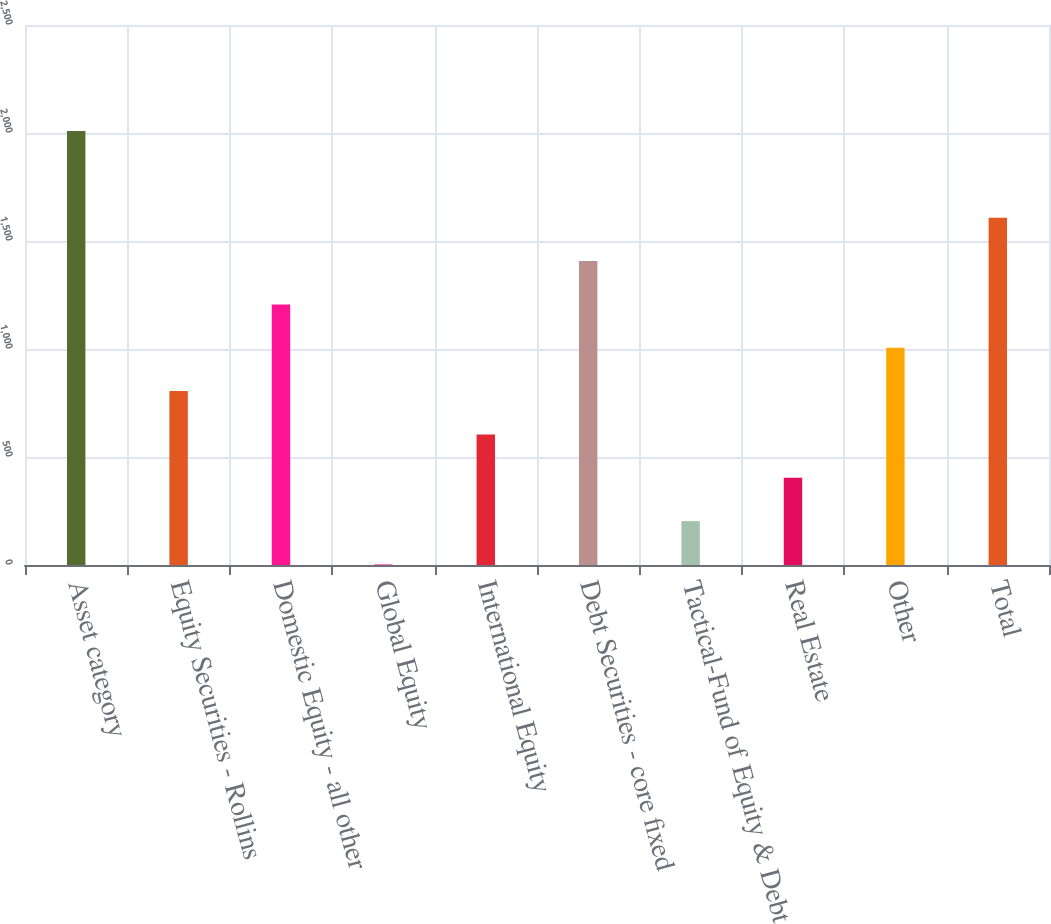Convert chart to OTSL. <chart><loc_0><loc_0><loc_500><loc_500><bar_chart><fcel>Asset category<fcel>Equity Securities - Rollins<fcel>Domestic Equity - all other<fcel>Global Equity<fcel>International Equity<fcel>Debt Securities - core fixed<fcel>Tactical-Fund of Equity & Debt<fcel>Real Estate<fcel>Other<fcel>Total<nl><fcel>2009<fcel>805.1<fcel>1206.4<fcel>2.5<fcel>604.45<fcel>1407.05<fcel>203.15<fcel>403.8<fcel>1005.75<fcel>1607.7<nl></chart> 